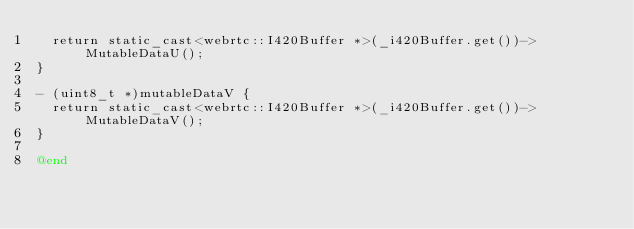<code> <loc_0><loc_0><loc_500><loc_500><_ObjectiveC_>  return static_cast<webrtc::I420Buffer *>(_i420Buffer.get())->MutableDataU();
}

- (uint8_t *)mutableDataV {
  return static_cast<webrtc::I420Buffer *>(_i420Buffer.get())->MutableDataV();
}

@end
</code> 